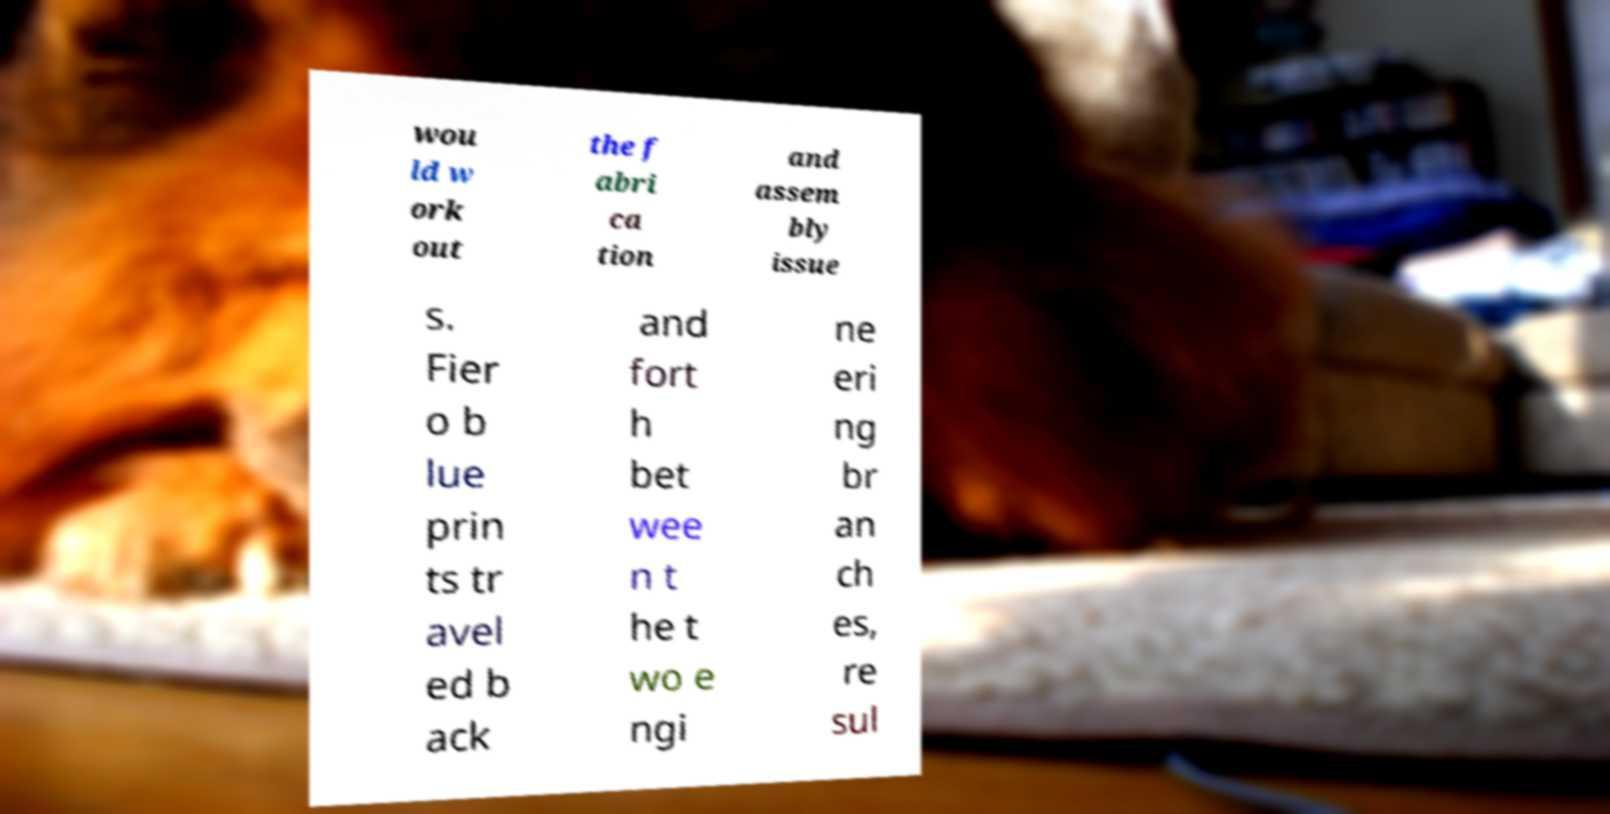Could you assist in decoding the text presented in this image and type it out clearly? wou ld w ork out the f abri ca tion and assem bly issue s. Fier o b lue prin ts tr avel ed b ack and fort h bet wee n t he t wo e ngi ne eri ng br an ch es, re sul 